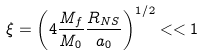Convert formula to latex. <formula><loc_0><loc_0><loc_500><loc_500>\xi = \left ( 4 \frac { M _ { f } } { M _ { 0 } } \frac { R _ { N S } } { a _ { 0 } } \right ) ^ { 1 / 2 } < < 1</formula> 